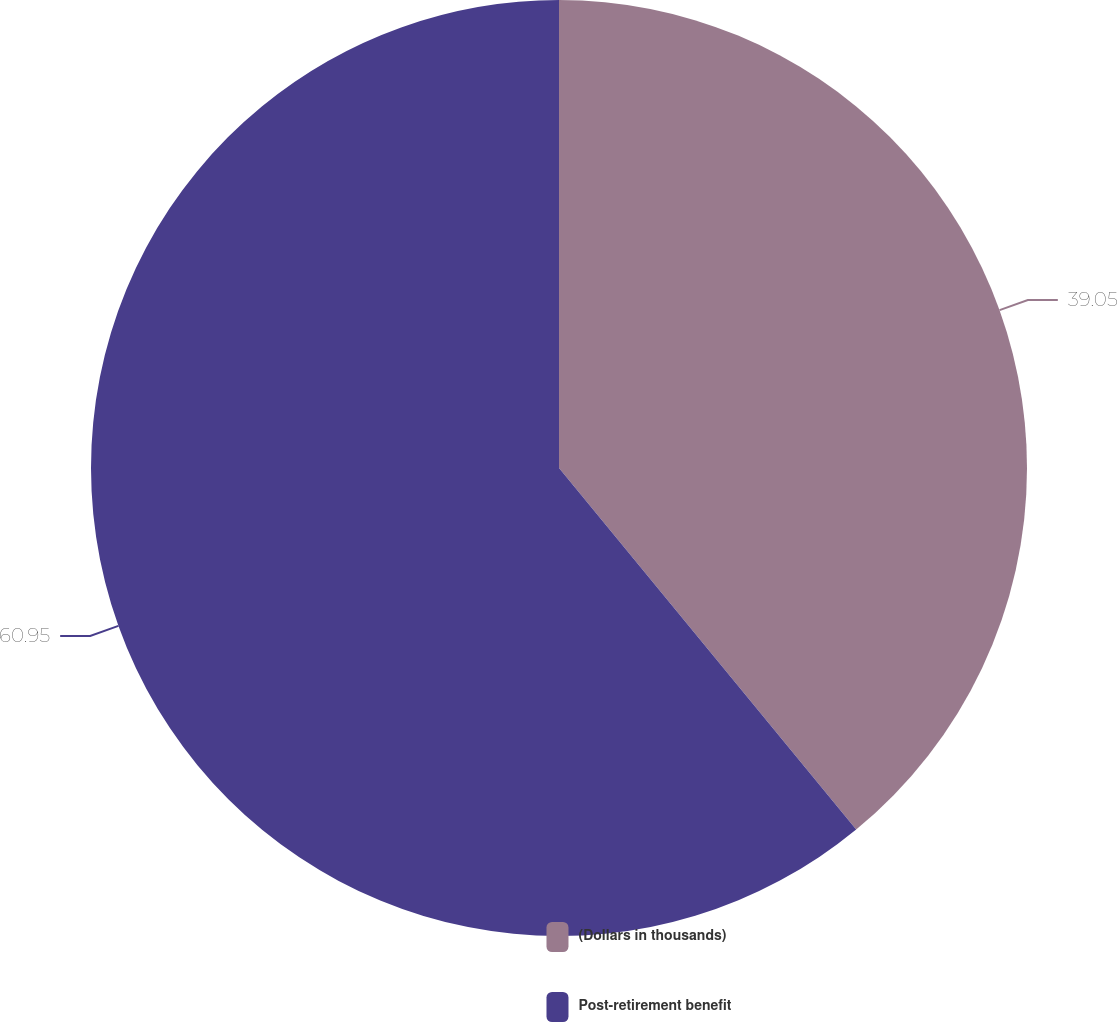Convert chart. <chart><loc_0><loc_0><loc_500><loc_500><pie_chart><fcel>(Dollars in thousands)<fcel>Post-retirement benefit<nl><fcel>39.05%<fcel>60.95%<nl></chart> 